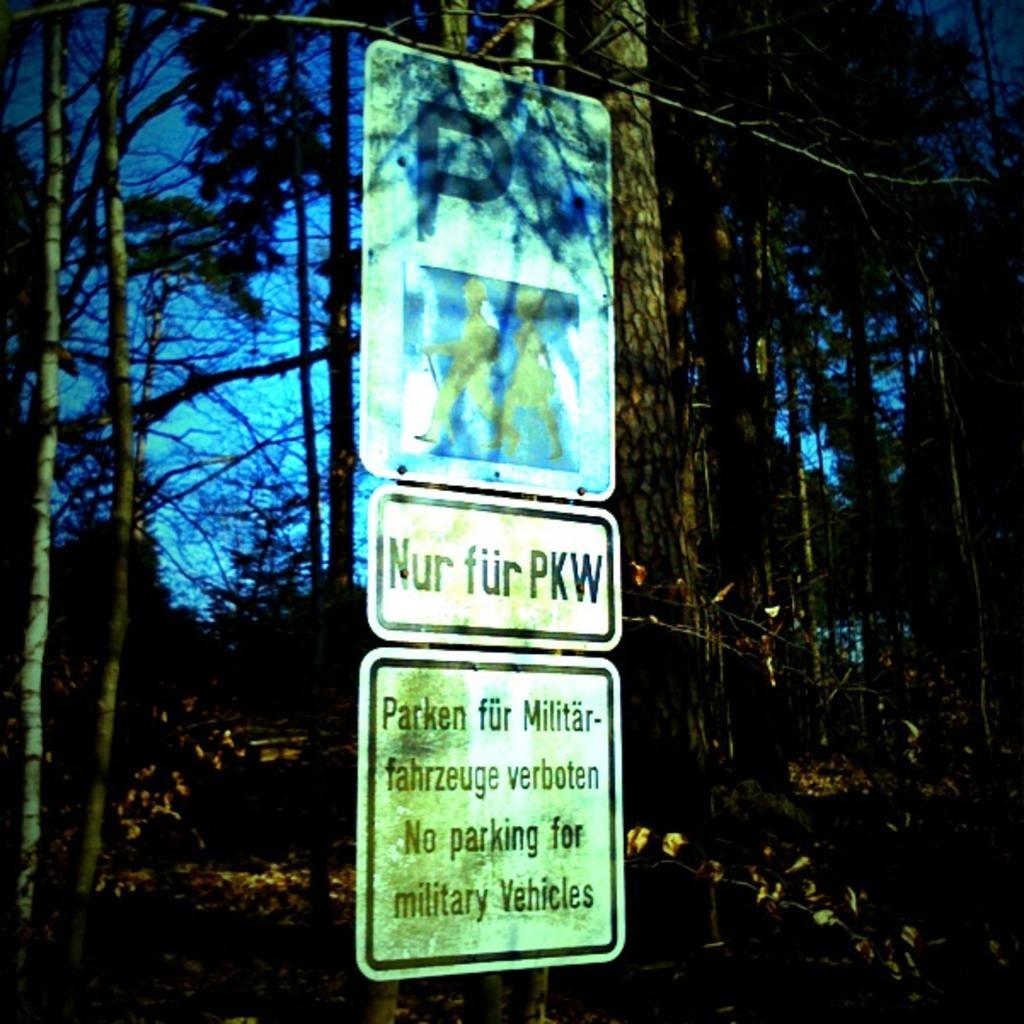In one or two sentences, can you explain what this image depicts? In this picture we can see three boards in the front, there is some text on these boards, there are trees in the background, we can also see the sky in the background. 